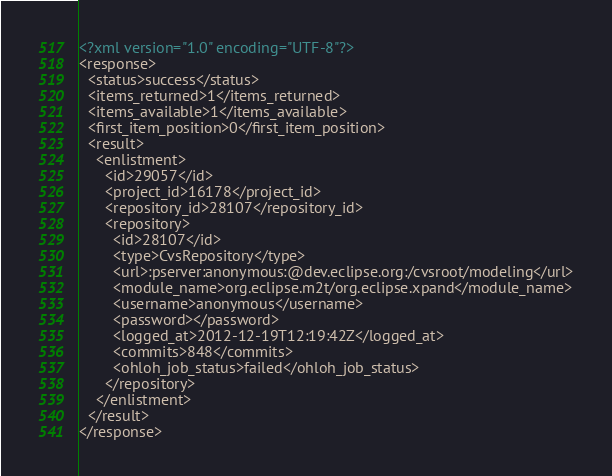<code> <loc_0><loc_0><loc_500><loc_500><_XML_><?xml version="1.0" encoding="UTF-8"?>
<response>
  <status>success</status>
  <items_returned>1</items_returned>
  <items_available>1</items_available>
  <first_item_position>0</first_item_position>
  <result>
    <enlistment>
      <id>29057</id>
      <project_id>16178</project_id>
      <repository_id>28107</repository_id>
      <repository>
        <id>28107</id>
        <type>CvsRepository</type>
        <url>:pserver:anonymous:@dev.eclipse.org:/cvsroot/modeling</url>
        <module_name>org.eclipse.m2t/org.eclipse.xpand</module_name>
        <username>anonymous</username>
        <password></password>
        <logged_at>2012-12-19T12:19:42Z</logged_at>
        <commits>848</commits>
        <ohloh_job_status>failed</ohloh_job_status>
      </repository>
    </enlistment>
  </result>
</response>
</code> 